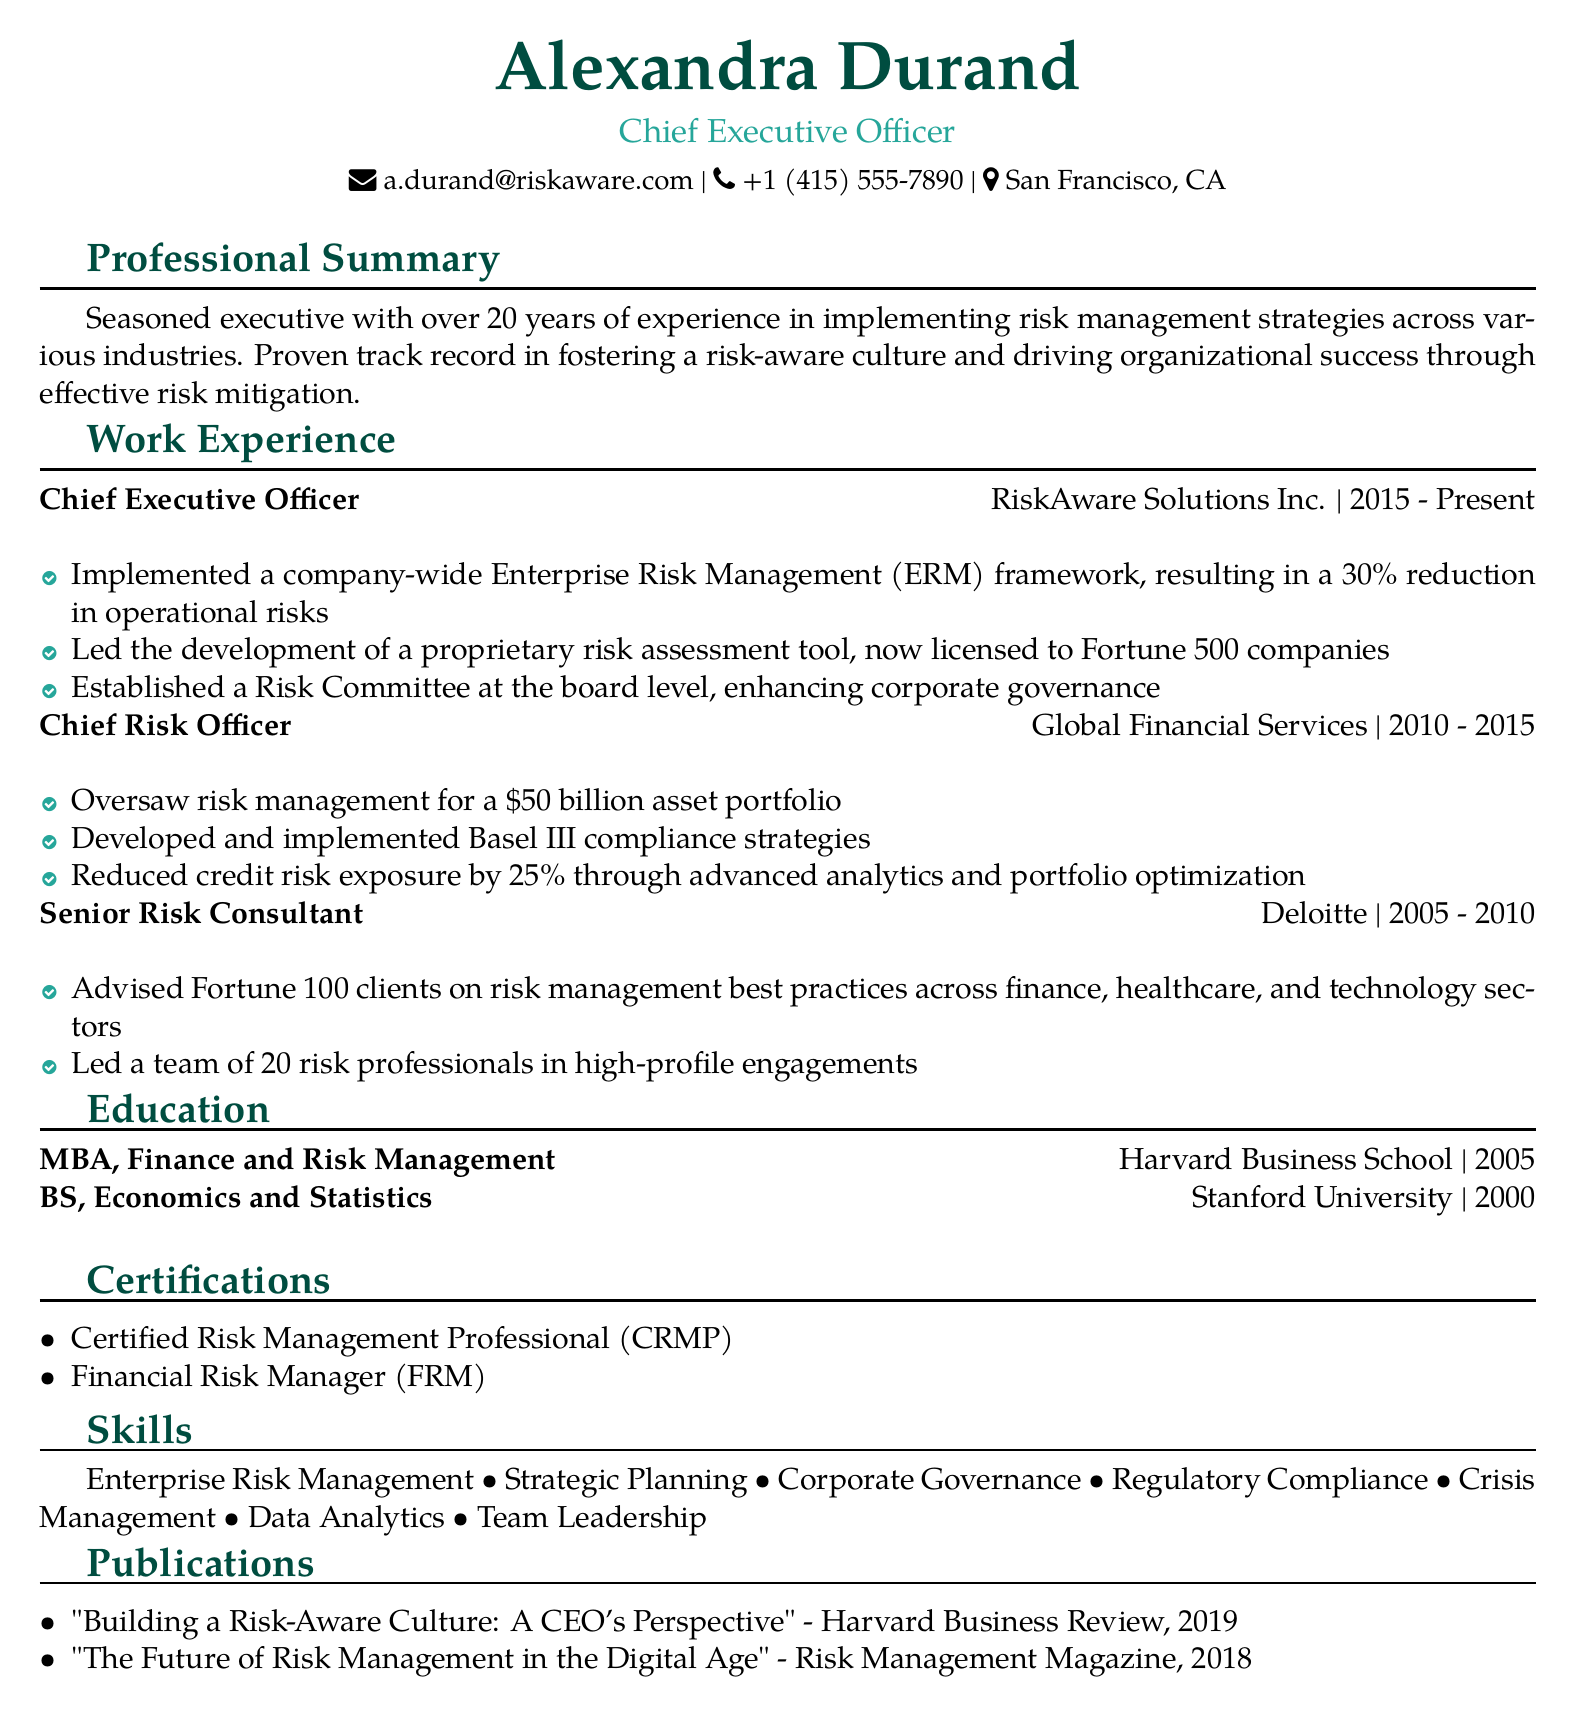What is the current position of Alexandra Durand? The document lists her current position as Chief Executive Officer.
Answer: Chief Executive Officer In which city is Alexandra Durand located? The document specifies her location as San Francisco, CA.
Answer: San Francisco, CA How many years of experience does Alexandra Durand have? The professional summary states she has over 20 years of experience.
Answer: 20 years What framework did Alexandra implement at RiskAware Solutions Inc.? The document states she implemented a company-wide Enterprise Risk Management (ERM) framework.
Answer: Enterprise Risk Management (ERM) What is one of the certifications Alexandra holds? The document lists several certifications, one of which is Certified Risk Management Professional.
Answer: Certified Risk Management Professional Which company did Alexandra work for as Chief Risk Officer? The work experience section indicates she worked for Global Financial Services in that role.
Answer: Global Financial Services What significant reduction in operational risks did Alexandra achieve? The document notes a 30% reduction in operational risks due to her initiatives.
Answer: 30% How many publications are listed in Alexandra's CV? The publications section shows that there are two publications listed.
Answer: 2 Which degree did Alexandra earn from Harvard Business School? The education section lists her degree as MBA, Finance and Risk Management.
Answer: MBA, Finance and Risk Management 